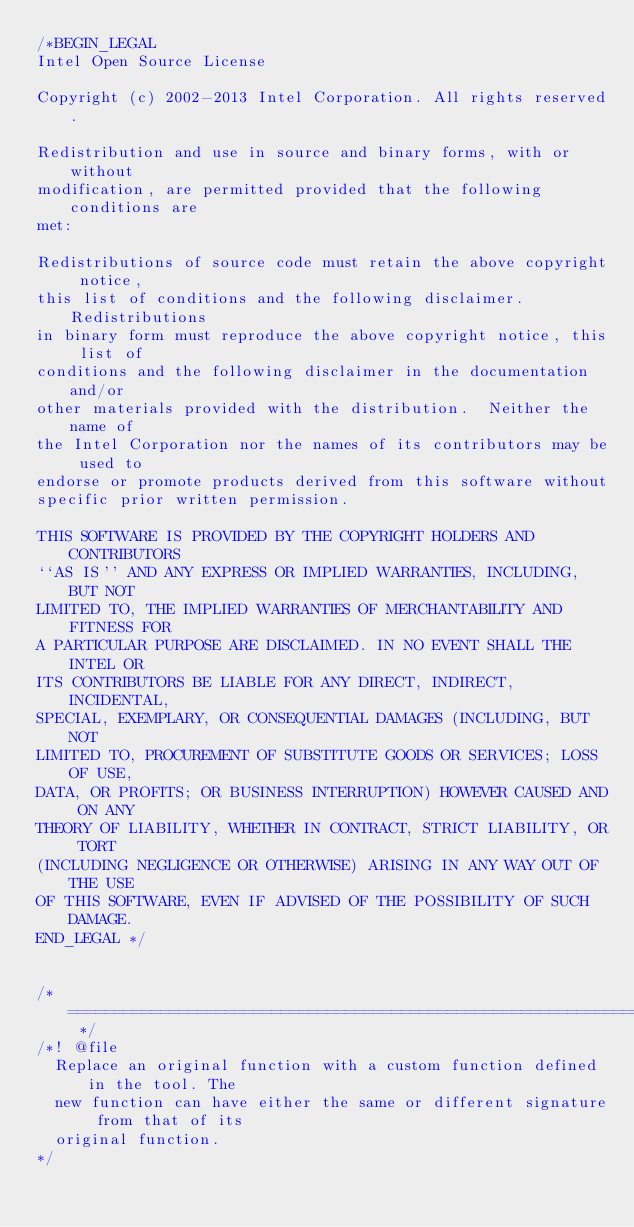Convert code to text. <code><loc_0><loc_0><loc_500><loc_500><_C++_>/*BEGIN_LEGAL 
Intel Open Source License 

Copyright (c) 2002-2013 Intel Corporation. All rights reserved.
 
Redistribution and use in source and binary forms, with or without
modification, are permitted provided that the following conditions are
met:

Redistributions of source code must retain the above copyright notice,
this list of conditions and the following disclaimer.  Redistributions
in binary form must reproduce the above copyright notice, this list of
conditions and the following disclaimer in the documentation and/or
other materials provided with the distribution.  Neither the name of
the Intel Corporation nor the names of its contributors may be used to
endorse or promote products derived from this software without
specific prior written permission.
 
THIS SOFTWARE IS PROVIDED BY THE COPYRIGHT HOLDERS AND CONTRIBUTORS
``AS IS'' AND ANY EXPRESS OR IMPLIED WARRANTIES, INCLUDING, BUT NOT
LIMITED TO, THE IMPLIED WARRANTIES OF MERCHANTABILITY AND FITNESS FOR
A PARTICULAR PURPOSE ARE DISCLAIMED. IN NO EVENT SHALL THE INTEL OR
ITS CONTRIBUTORS BE LIABLE FOR ANY DIRECT, INDIRECT, INCIDENTAL,
SPECIAL, EXEMPLARY, OR CONSEQUENTIAL DAMAGES (INCLUDING, BUT NOT
LIMITED TO, PROCUREMENT OF SUBSTITUTE GOODS OR SERVICES; LOSS OF USE,
DATA, OR PROFITS; OR BUSINESS INTERRUPTION) HOWEVER CAUSED AND ON ANY
THEORY OF LIABILITY, WHETHER IN CONTRACT, STRICT LIABILITY, OR TORT
(INCLUDING NEGLIGENCE OR OTHERWISE) ARISING IN ANY WAY OUT OF THE USE
OF THIS SOFTWARE, EVEN IF ADVISED OF THE POSSIBILITY OF SUCH DAMAGE.
END_LEGAL */


/* ===================================================================== */
/*! @file
  Replace an original function with a custom function defined in the tool. The
  new function can have either the same or different signature from that of its
  original function.
*/
</code> 